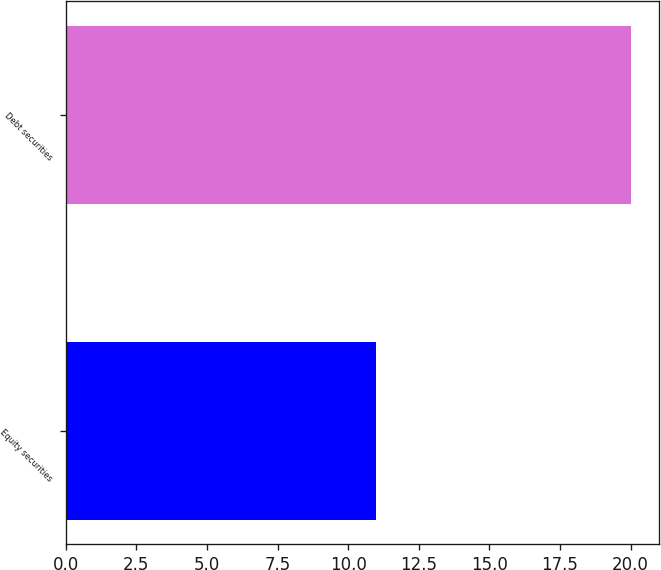<chart> <loc_0><loc_0><loc_500><loc_500><bar_chart><fcel>Equity securities<fcel>Debt securities<nl><fcel>11<fcel>20<nl></chart> 